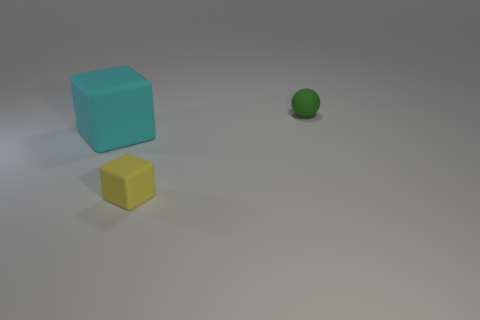Add 1 rubber things. How many objects exist? 4 Subtract all balls. How many objects are left? 2 Subtract all cyan rubber objects. Subtract all red objects. How many objects are left? 2 Add 1 small green objects. How many small green objects are left? 2 Add 3 cyan matte objects. How many cyan matte objects exist? 4 Subtract 0 red cylinders. How many objects are left? 3 